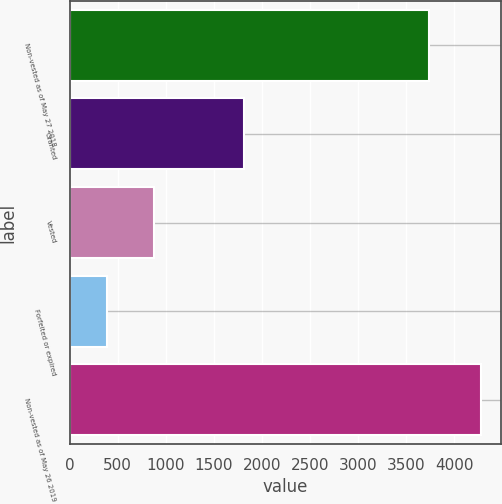<chart> <loc_0><loc_0><loc_500><loc_500><bar_chart><fcel>Non-vested as of May 27 2018<fcel>Granted<fcel>Vested<fcel>Forfeited or expired<fcel>Non-vested as of May 26 2019<nl><fcel>3731.8<fcel>1814.5<fcel>880.6<fcel>393.4<fcel>4272.3<nl></chart> 